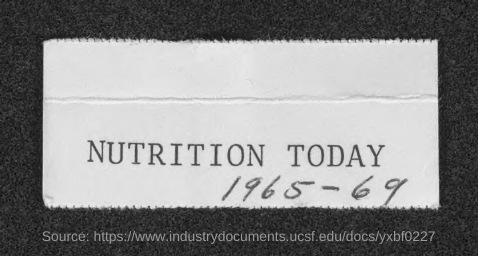Mention a couple of crucial points in this snapshot. The journal 'NUTRITION TODAY' is mentioned in this context. 